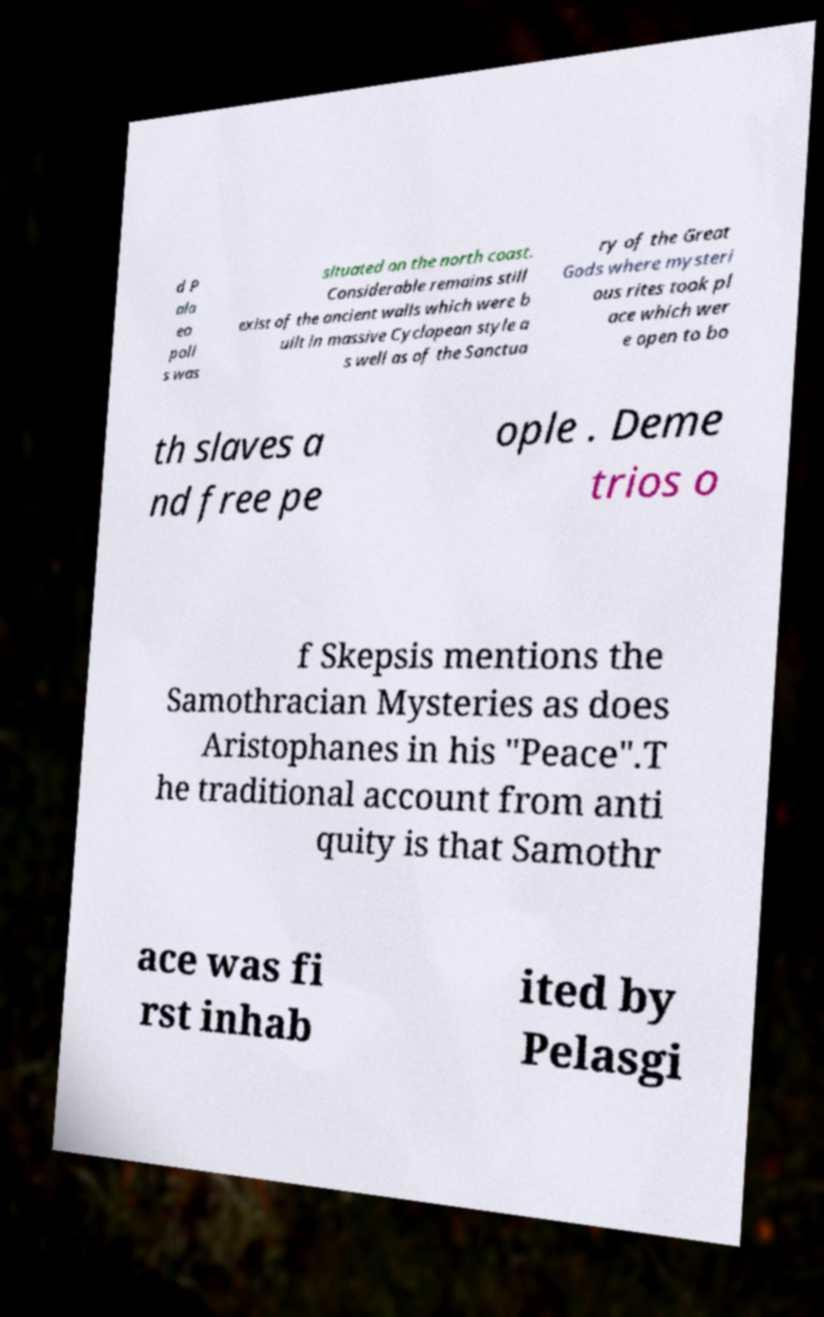Could you extract and type out the text from this image? d P ala eo poli s was situated on the north coast. Considerable remains still exist of the ancient walls which were b uilt in massive Cyclopean style a s well as of the Sanctua ry of the Great Gods where mysteri ous rites took pl ace which wer e open to bo th slaves a nd free pe ople . Deme trios o f Skepsis mentions the Samothracian Mysteries as does Aristophanes in his "Peace".T he traditional account from anti quity is that Samothr ace was fi rst inhab ited by Pelasgi 